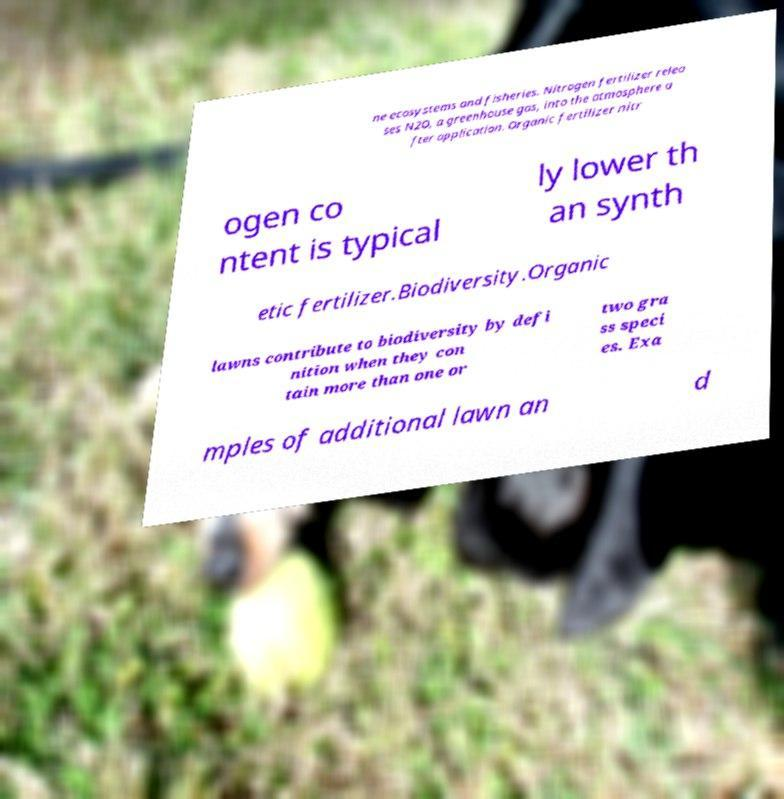Can you read and provide the text displayed in the image?This photo seems to have some interesting text. Can you extract and type it out for me? ne ecosystems and fisheries. Nitrogen fertilizer relea ses N2O, a greenhouse gas, into the atmosphere a fter application. Organic fertilizer nitr ogen co ntent is typical ly lower th an synth etic fertilizer.Biodiversity.Organic lawns contribute to biodiversity by defi nition when they con tain more than one or two gra ss speci es. Exa mples of additional lawn an d 